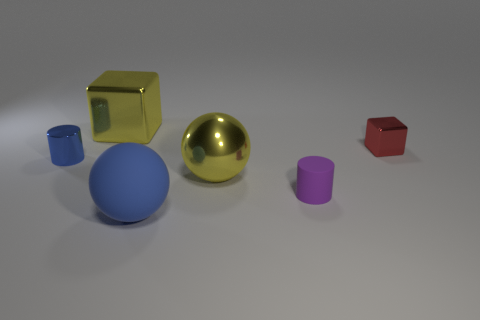Add 4 large red shiny blocks. How many objects exist? 10 Subtract all blocks. How many objects are left? 4 Subtract 0 green spheres. How many objects are left? 6 Subtract all small gray rubber balls. Subtract all yellow metallic cubes. How many objects are left? 5 Add 4 big yellow metallic balls. How many big yellow metallic balls are left? 5 Add 6 small purple objects. How many small purple objects exist? 7 